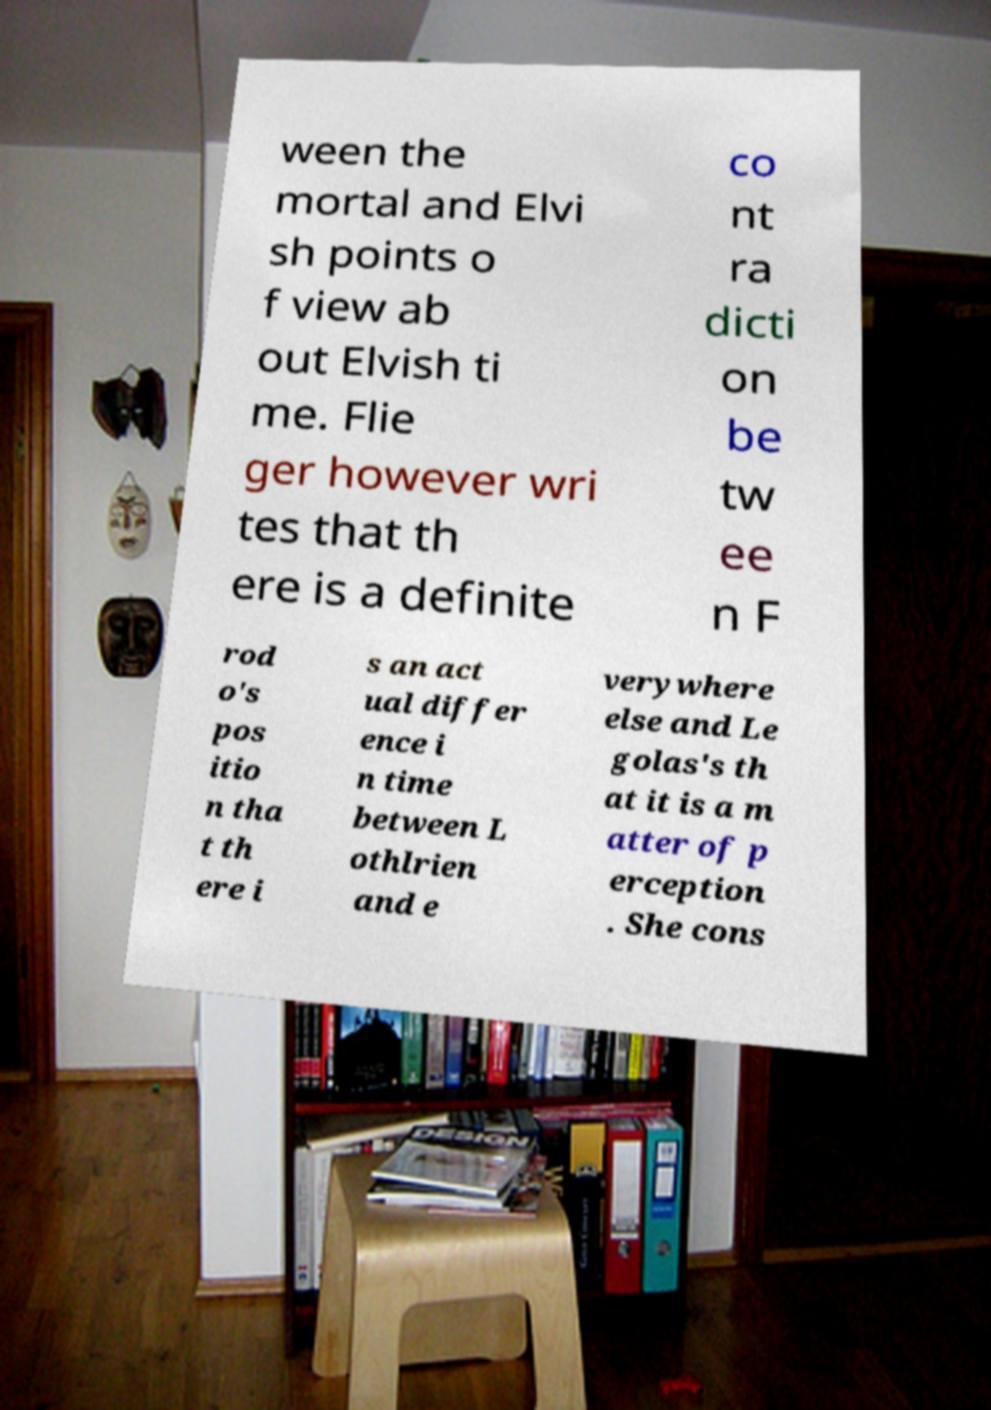Could you extract and type out the text from this image? ween the mortal and Elvi sh points o f view ab out Elvish ti me. Flie ger however wri tes that th ere is a definite co nt ra dicti on be tw ee n F rod o's pos itio n tha t th ere i s an act ual differ ence i n time between L othlrien and e verywhere else and Le golas's th at it is a m atter of p erception . She cons 